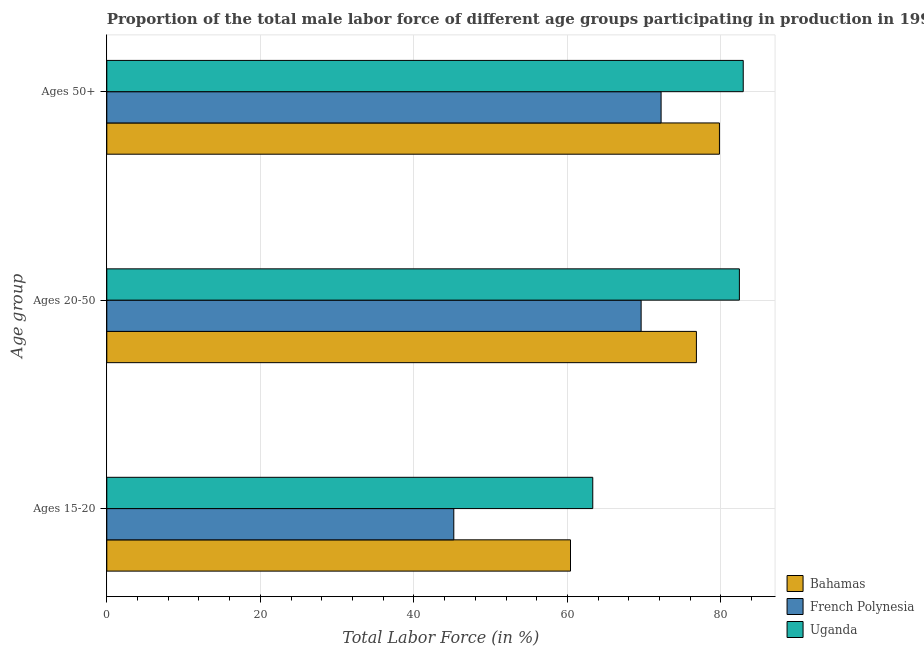How many different coloured bars are there?
Offer a very short reply. 3. How many groups of bars are there?
Your answer should be compact. 3. Are the number of bars on each tick of the Y-axis equal?
Ensure brevity in your answer.  Yes. How many bars are there on the 1st tick from the bottom?
Make the answer very short. 3. What is the label of the 1st group of bars from the top?
Provide a short and direct response. Ages 50+. What is the percentage of male labor force within the age group 15-20 in Uganda?
Your answer should be compact. 63.3. Across all countries, what is the maximum percentage of male labor force within the age group 15-20?
Your answer should be very brief. 63.3. Across all countries, what is the minimum percentage of male labor force within the age group 15-20?
Give a very brief answer. 45.2. In which country was the percentage of male labor force within the age group 15-20 maximum?
Your answer should be compact. Uganda. In which country was the percentage of male labor force within the age group 15-20 minimum?
Provide a succinct answer. French Polynesia. What is the total percentage of male labor force within the age group 20-50 in the graph?
Keep it short and to the point. 228.8. What is the difference between the percentage of male labor force above age 50 in Bahamas and that in French Polynesia?
Ensure brevity in your answer.  7.6. What is the difference between the percentage of male labor force above age 50 in Bahamas and the percentage of male labor force within the age group 15-20 in French Polynesia?
Provide a short and direct response. 34.6. What is the average percentage of male labor force within the age group 20-50 per country?
Your answer should be compact. 76.27. What is the difference between the percentage of male labor force above age 50 and percentage of male labor force within the age group 20-50 in Uganda?
Your answer should be compact. 0.5. In how many countries, is the percentage of male labor force within the age group 20-50 greater than 72 %?
Ensure brevity in your answer.  2. What is the ratio of the percentage of male labor force within the age group 20-50 in Uganda to that in French Polynesia?
Keep it short and to the point. 1.18. Is the percentage of male labor force within the age group 15-20 in French Polynesia less than that in Bahamas?
Your answer should be very brief. Yes. What is the difference between the highest and the second highest percentage of male labor force above age 50?
Ensure brevity in your answer.  3.1. What is the difference between the highest and the lowest percentage of male labor force within the age group 20-50?
Ensure brevity in your answer.  12.8. In how many countries, is the percentage of male labor force within the age group 20-50 greater than the average percentage of male labor force within the age group 20-50 taken over all countries?
Your response must be concise. 2. Is the sum of the percentage of male labor force within the age group 20-50 in Bahamas and French Polynesia greater than the maximum percentage of male labor force above age 50 across all countries?
Keep it short and to the point. Yes. What does the 1st bar from the top in Ages 50+ represents?
Give a very brief answer. Uganda. What does the 3rd bar from the bottom in Ages 20-50 represents?
Ensure brevity in your answer.  Uganda. How many bars are there?
Make the answer very short. 9. Are all the bars in the graph horizontal?
Give a very brief answer. Yes. How many countries are there in the graph?
Your answer should be very brief. 3. Are the values on the major ticks of X-axis written in scientific E-notation?
Make the answer very short. No. Does the graph contain any zero values?
Provide a succinct answer. No. Where does the legend appear in the graph?
Make the answer very short. Bottom right. What is the title of the graph?
Ensure brevity in your answer.  Proportion of the total male labor force of different age groups participating in production in 1997. What is the label or title of the X-axis?
Your response must be concise. Total Labor Force (in %). What is the label or title of the Y-axis?
Your answer should be compact. Age group. What is the Total Labor Force (in %) in Bahamas in Ages 15-20?
Keep it short and to the point. 60.4. What is the Total Labor Force (in %) of French Polynesia in Ages 15-20?
Ensure brevity in your answer.  45.2. What is the Total Labor Force (in %) of Uganda in Ages 15-20?
Make the answer very short. 63.3. What is the Total Labor Force (in %) in Bahamas in Ages 20-50?
Give a very brief answer. 76.8. What is the Total Labor Force (in %) in French Polynesia in Ages 20-50?
Your answer should be very brief. 69.6. What is the Total Labor Force (in %) in Uganda in Ages 20-50?
Offer a very short reply. 82.4. What is the Total Labor Force (in %) of Bahamas in Ages 50+?
Your answer should be compact. 79.8. What is the Total Labor Force (in %) in French Polynesia in Ages 50+?
Provide a succinct answer. 72.2. What is the Total Labor Force (in %) in Uganda in Ages 50+?
Your answer should be very brief. 82.9. Across all Age group, what is the maximum Total Labor Force (in %) in Bahamas?
Offer a terse response. 79.8. Across all Age group, what is the maximum Total Labor Force (in %) of French Polynesia?
Your response must be concise. 72.2. Across all Age group, what is the maximum Total Labor Force (in %) in Uganda?
Ensure brevity in your answer.  82.9. Across all Age group, what is the minimum Total Labor Force (in %) in Bahamas?
Keep it short and to the point. 60.4. Across all Age group, what is the minimum Total Labor Force (in %) of French Polynesia?
Your answer should be compact. 45.2. Across all Age group, what is the minimum Total Labor Force (in %) in Uganda?
Offer a very short reply. 63.3. What is the total Total Labor Force (in %) in Bahamas in the graph?
Your answer should be compact. 217. What is the total Total Labor Force (in %) in French Polynesia in the graph?
Keep it short and to the point. 187. What is the total Total Labor Force (in %) of Uganda in the graph?
Offer a terse response. 228.6. What is the difference between the Total Labor Force (in %) of Bahamas in Ages 15-20 and that in Ages 20-50?
Make the answer very short. -16.4. What is the difference between the Total Labor Force (in %) in French Polynesia in Ages 15-20 and that in Ages 20-50?
Keep it short and to the point. -24.4. What is the difference between the Total Labor Force (in %) in Uganda in Ages 15-20 and that in Ages 20-50?
Give a very brief answer. -19.1. What is the difference between the Total Labor Force (in %) in Bahamas in Ages 15-20 and that in Ages 50+?
Offer a terse response. -19.4. What is the difference between the Total Labor Force (in %) of Uganda in Ages 15-20 and that in Ages 50+?
Offer a very short reply. -19.6. What is the difference between the Total Labor Force (in %) in Bahamas in Ages 20-50 and that in Ages 50+?
Your answer should be very brief. -3. What is the difference between the Total Labor Force (in %) in Bahamas in Ages 15-20 and the Total Labor Force (in %) in French Polynesia in Ages 20-50?
Make the answer very short. -9.2. What is the difference between the Total Labor Force (in %) of Bahamas in Ages 15-20 and the Total Labor Force (in %) of Uganda in Ages 20-50?
Provide a succinct answer. -22. What is the difference between the Total Labor Force (in %) of French Polynesia in Ages 15-20 and the Total Labor Force (in %) of Uganda in Ages 20-50?
Provide a short and direct response. -37.2. What is the difference between the Total Labor Force (in %) of Bahamas in Ages 15-20 and the Total Labor Force (in %) of French Polynesia in Ages 50+?
Offer a terse response. -11.8. What is the difference between the Total Labor Force (in %) in Bahamas in Ages 15-20 and the Total Labor Force (in %) in Uganda in Ages 50+?
Ensure brevity in your answer.  -22.5. What is the difference between the Total Labor Force (in %) in French Polynesia in Ages 15-20 and the Total Labor Force (in %) in Uganda in Ages 50+?
Your response must be concise. -37.7. What is the difference between the Total Labor Force (in %) of French Polynesia in Ages 20-50 and the Total Labor Force (in %) of Uganda in Ages 50+?
Provide a succinct answer. -13.3. What is the average Total Labor Force (in %) of Bahamas per Age group?
Provide a short and direct response. 72.33. What is the average Total Labor Force (in %) of French Polynesia per Age group?
Your answer should be very brief. 62.33. What is the average Total Labor Force (in %) of Uganda per Age group?
Provide a short and direct response. 76.2. What is the difference between the Total Labor Force (in %) in Bahamas and Total Labor Force (in %) in French Polynesia in Ages 15-20?
Give a very brief answer. 15.2. What is the difference between the Total Labor Force (in %) in Bahamas and Total Labor Force (in %) in Uganda in Ages 15-20?
Offer a very short reply. -2.9. What is the difference between the Total Labor Force (in %) in French Polynesia and Total Labor Force (in %) in Uganda in Ages 15-20?
Your answer should be very brief. -18.1. What is the difference between the Total Labor Force (in %) of Bahamas and Total Labor Force (in %) of French Polynesia in Ages 50+?
Your answer should be compact. 7.6. What is the difference between the Total Labor Force (in %) in Bahamas and Total Labor Force (in %) in Uganda in Ages 50+?
Your answer should be very brief. -3.1. What is the difference between the Total Labor Force (in %) in French Polynesia and Total Labor Force (in %) in Uganda in Ages 50+?
Your answer should be very brief. -10.7. What is the ratio of the Total Labor Force (in %) of Bahamas in Ages 15-20 to that in Ages 20-50?
Your answer should be compact. 0.79. What is the ratio of the Total Labor Force (in %) in French Polynesia in Ages 15-20 to that in Ages 20-50?
Offer a very short reply. 0.65. What is the ratio of the Total Labor Force (in %) in Uganda in Ages 15-20 to that in Ages 20-50?
Provide a short and direct response. 0.77. What is the ratio of the Total Labor Force (in %) of Bahamas in Ages 15-20 to that in Ages 50+?
Your answer should be compact. 0.76. What is the ratio of the Total Labor Force (in %) in French Polynesia in Ages 15-20 to that in Ages 50+?
Your answer should be very brief. 0.63. What is the ratio of the Total Labor Force (in %) of Uganda in Ages 15-20 to that in Ages 50+?
Offer a very short reply. 0.76. What is the ratio of the Total Labor Force (in %) of Bahamas in Ages 20-50 to that in Ages 50+?
Give a very brief answer. 0.96. What is the difference between the highest and the second highest Total Labor Force (in %) of Bahamas?
Make the answer very short. 3. What is the difference between the highest and the lowest Total Labor Force (in %) in Uganda?
Make the answer very short. 19.6. 